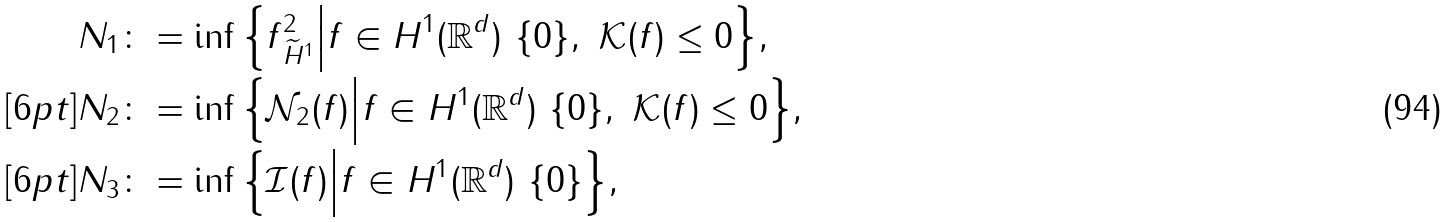Convert formula to latex. <formula><loc_0><loc_0><loc_500><loc_500>N _ { 1 } & \colon = \inf { \left \{ \| f \| _ { \widetilde { H } ^ { 1 } } ^ { 2 } \Big | f \in H ^ { 1 } ( \mathbb { R } ^ { d } ) \ \{ 0 \} , \ \mathcal { K } ( f ) \leq 0 \right \} } , \\ [ 6 p t ] N _ { 2 } & \colon = \inf { \left \{ \mathcal { N } _ { 2 } ( f ) \Big | f \in H ^ { 1 } ( \mathbb { R } ^ { d } ) \ \{ 0 \} , \ \mathcal { K } ( f ) \leq 0 \right \} } , \\ [ 6 p t ] N _ { 3 } & \colon = \inf { \Big \{ \mathcal { I } ( f ) \Big | f \in H ^ { 1 } ( \mathbb { R } ^ { d } ) \ \{ 0 \} \Big \} } ,</formula> 